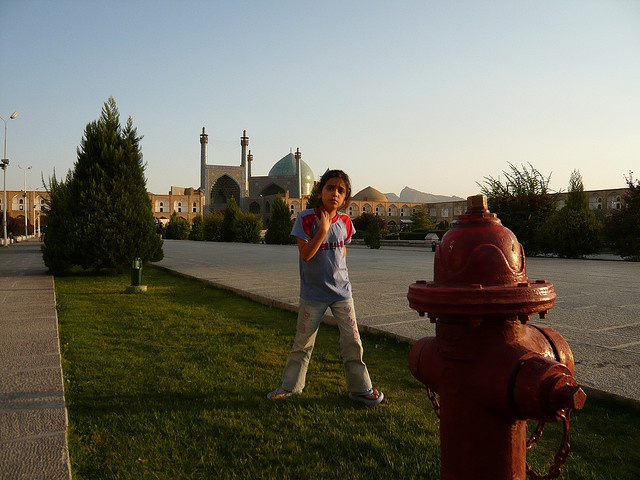Describe the objects in this image and their specific colors. I can see fire hydrant in gray, black, maroon, and brown tones and people in gray, black, and maroon tones in this image. 